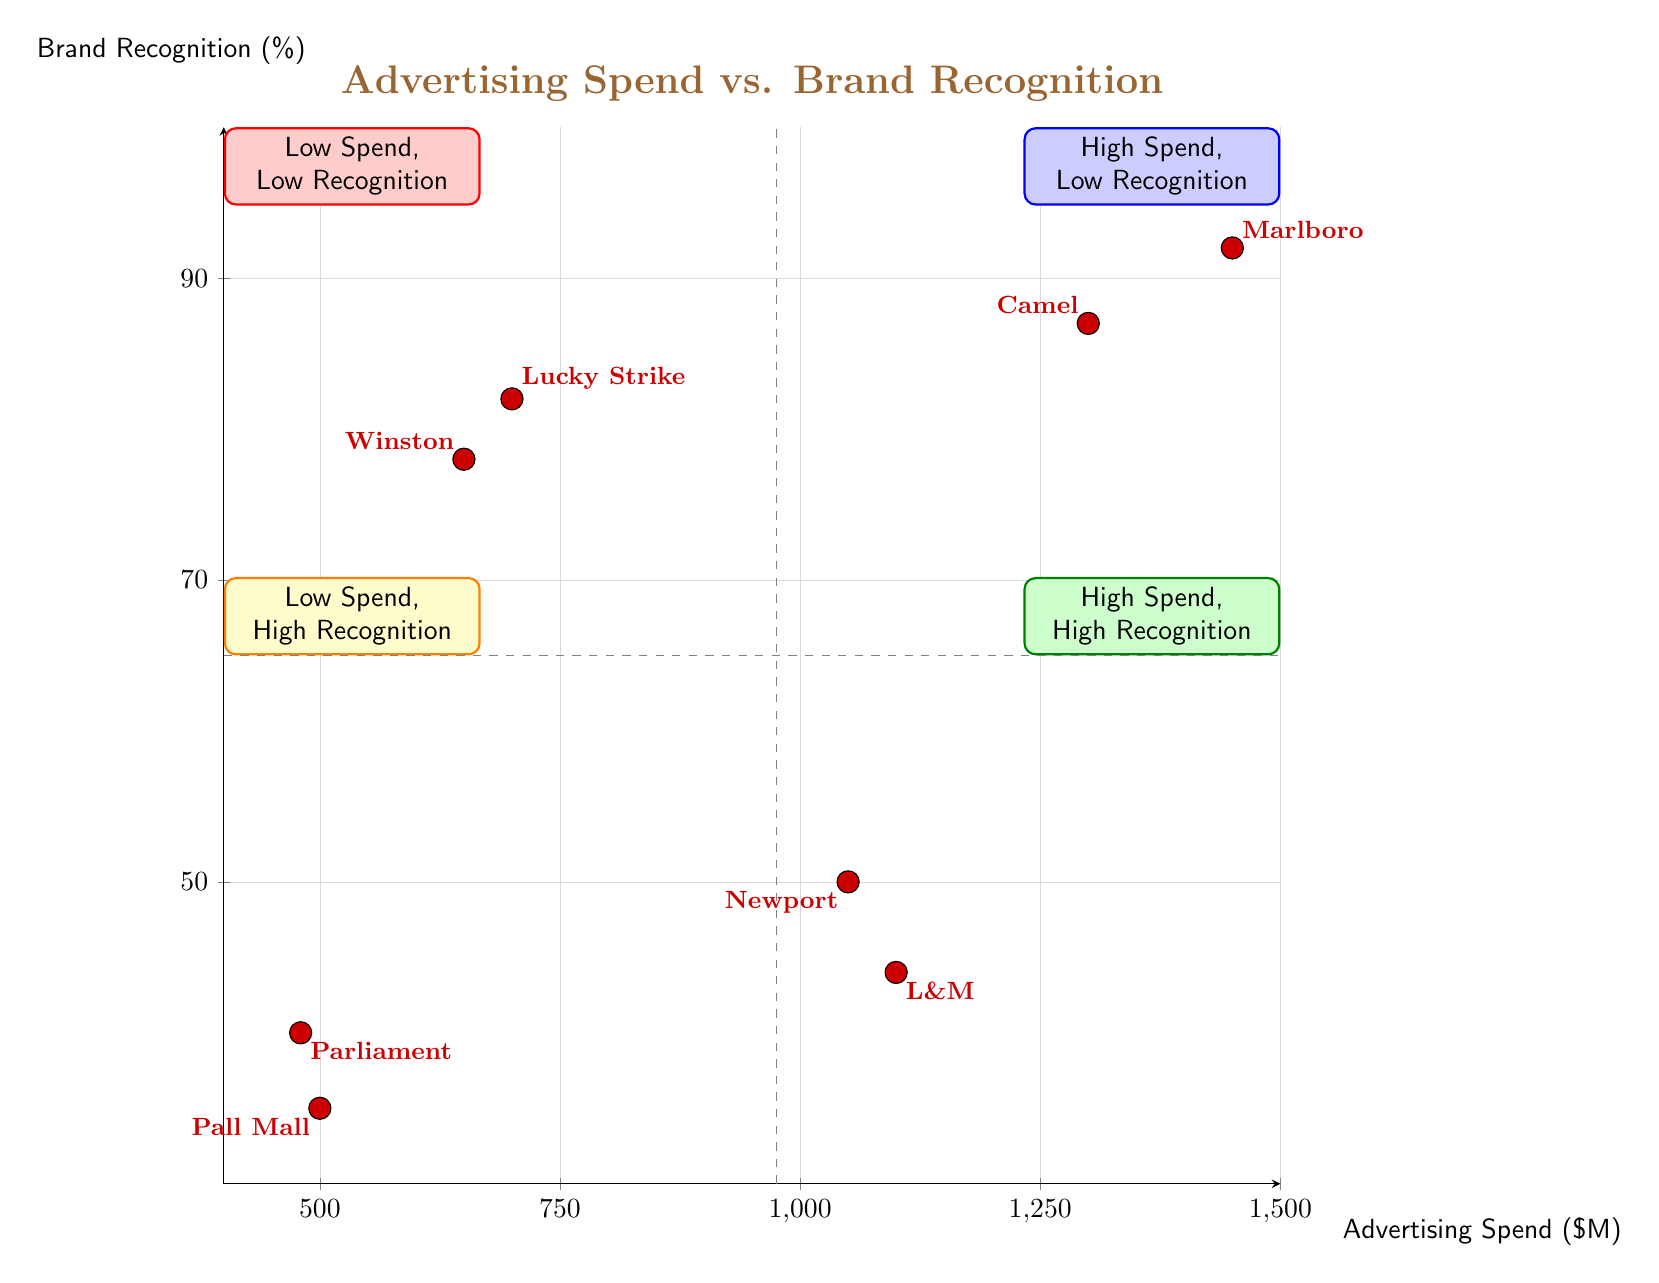What brands are in the High Spend, High Recognition quadrant? According to the diagram, the brands located in the High Spend, High Recognition quadrant are Marlboro and Camel. They are positioned in the upper right quadrant of the chart.
Answer: Marlboro, Camel What is the advertising spend of L&M? The diagram shows that L&M has an advertising spend of 1100, which is indicated by its positioning in the High Spend, Low Recognition quadrant.
Answer: 1100 How many companies have high brand recognition (above 80)? The diagram indicates that there are four companies with high brand recognition (above 80): Marlboro, Camel, Winston, and Lucky Strike. By evaluating each brand's brand recognition percentages, we can see that these four exceed the 80% threshold.
Answer: 4 What brand has the lowest brand recognition? Upon examining the diagram, Pall Mall has the lowest brand recognition at 35, as indicated by its placement in the Low Spend, Low Recognition quadrant.
Answer: Pall Mall What is the brand recognition of Newport? The diagram displays that Newport has a brand recognition of 50, which can be identified in the High Spend, Low Recognition quadrant.
Answer: 50 Which quadrant contains brands with low spend and low recognition? The quadrant that contains brands with low spend and low brand recognition is the Low Spend, Low Recognition quadrant, where Pall Mall and Parliament are located.
Answer: Low Spend, Low Recognition Which brand has an advertising spend of 700? According to the chart, Lucky Strike has an advertising spend of 700, and it can be found in the Low Spend, High Recognition quadrant.
Answer: Lucky Strike What is the advertising spend of Camel? The diagram indicates that Camel has an advertising spend of 1300, reflected by its position in the High Spend, High Recognition quadrant.
Answer: 1300 How many companies have low spend (below 700)? The companies with low spend (below 700) are Pall Mall and Parliament. By reviewing their respective advertising spends of 500 and 480, it's clear that there are two companies fitting this criterion.
Answer: 2 